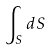<formula> <loc_0><loc_0><loc_500><loc_500>\int _ { S } d S</formula> 